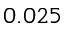Convert formula to latex. <formula><loc_0><loc_0><loc_500><loc_500>0 . 0 2 5</formula> 